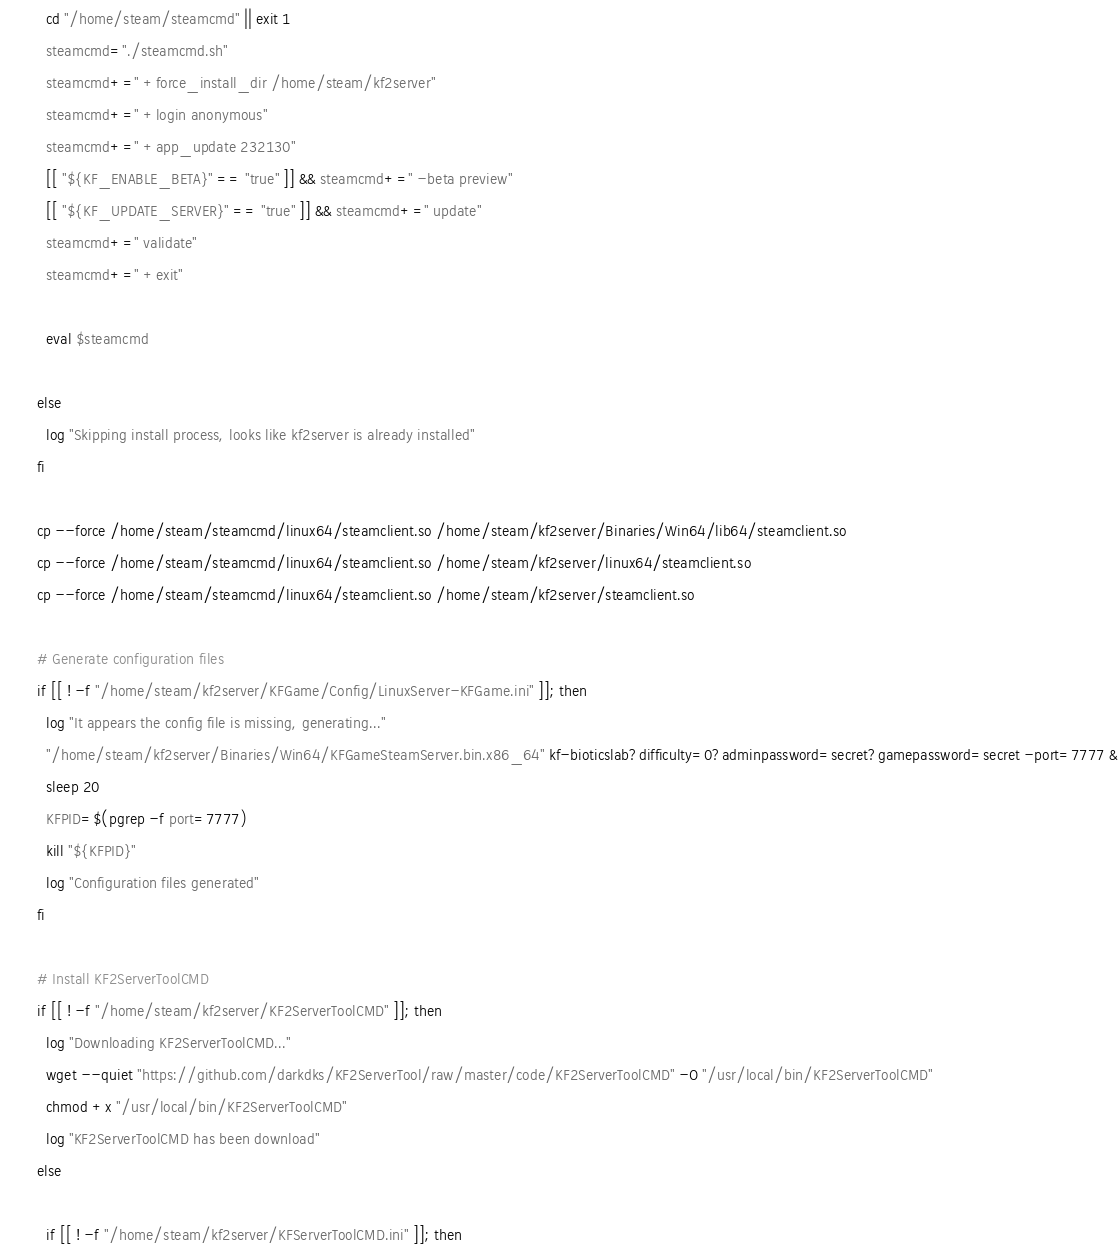<code> <loc_0><loc_0><loc_500><loc_500><_Bash_>  cd "/home/steam/steamcmd" || exit 1
  steamcmd="./steamcmd.sh"
  steamcmd+=" +force_install_dir /home/steam/kf2server"
  steamcmd+=" +login anonymous"
  steamcmd+=" +app_update 232130"
  [[ "${KF_ENABLE_BETA}" == "true" ]] && steamcmd+=" -beta preview"
  [[ "${KF_UPDATE_SERVER}" == "true" ]] && steamcmd+=" update"
  steamcmd+=" validate"
  steamcmd+=" +exit"

  eval $steamcmd

else
  log "Skipping install process, looks like kf2server is already installed"
fi

cp --force /home/steam/steamcmd/linux64/steamclient.so /home/steam/kf2server/Binaries/Win64/lib64/steamclient.so
cp --force /home/steam/steamcmd/linux64/steamclient.so /home/steam/kf2server/linux64/steamclient.so
cp --force /home/steam/steamcmd/linux64/steamclient.so /home/steam/kf2server/steamclient.so

# Generate configuration files
if [[ ! -f "/home/steam/kf2server/KFGame/Config/LinuxServer-KFGame.ini" ]]; then
  log "It appears the config file is missing, generating..."
  "/home/steam/kf2server/Binaries/Win64/KFGameSteamServer.bin.x86_64" kf-bioticslab?difficulty=0?adminpassword=secret?gamepassword=secret -port=7777 &
  sleep 20
  KFPID=$(pgrep -f port=7777)
  kill "${KFPID}"
  log "Configuration files generated"
fi

# Install KF2ServerToolCMD
if [[ ! -f "/home/steam/kf2server/KF2ServerToolCMD" ]]; then
  log "Downloading KF2ServerToolCMD..."
  wget --quiet "https://github.com/darkdks/KF2ServerTool/raw/master/code/KF2ServerToolCMD" -O "/usr/local/bin/KF2ServerToolCMD"
  chmod +x "/usr/local/bin/KF2ServerToolCMD"
  log "KF2ServerToolCMD has been download"
else

  if [[ ! -f "/home/steam/kf2server/KFServerToolCMD.ini" ]]; then</code> 